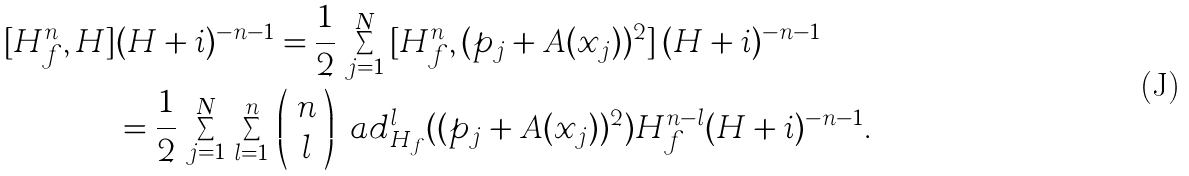<formula> <loc_0><loc_0><loc_500><loc_500>[ H _ { f } ^ { n } , H ] & ( H + i ) ^ { - n - 1 } = \frac { 1 } { 2 } \, \sum _ { j = 1 } ^ { N } \, [ H _ { f } ^ { n } , ( p _ { j } + A ( x _ { j } ) ) ^ { 2 } ] \, ( H + i ) ^ { - n - 1 } \\ & = \frac { 1 } { 2 } \, \sum _ { j = 1 } ^ { N } \, \sum _ { l = 1 } ^ { n } \, \left ( \begin{array} { c } n \\ l \end{array} \right ) \ a d _ { H _ { f } } ^ { l } ( ( p _ { j } + A ( x _ { j } ) ) ^ { 2 } ) H _ { f } ^ { n - l } ( H + i ) ^ { - n - 1 } .</formula> 